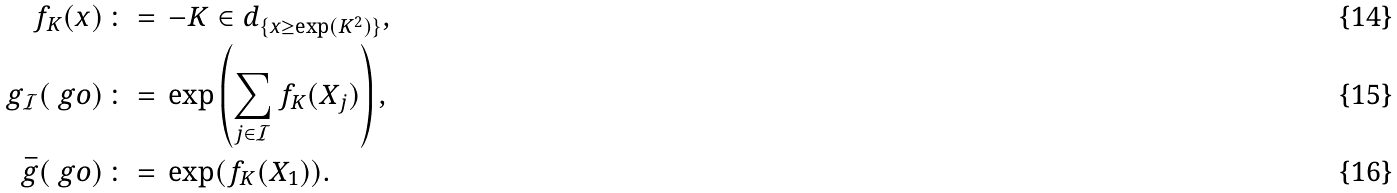<formula> <loc_0><loc_0><loc_500><loc_500>f _ { K } ( x ) \, & \colon = \, - K \in d _ { \{ x \geq \exp ( K ^ { 2 } ) \} } , \\ g _ { \mathcal { I } } ( \ g o ) \, & \colon = \, \exp \left ( \sum _ { j \in \mathcal { I } } f _ { K } ( X _ { j } ) \right ) , \\ \bar { g } ( \ g o ) \, & \colon = \, \exp ( f _ { K } ( X _ { 1 } ) ) .</formula> 